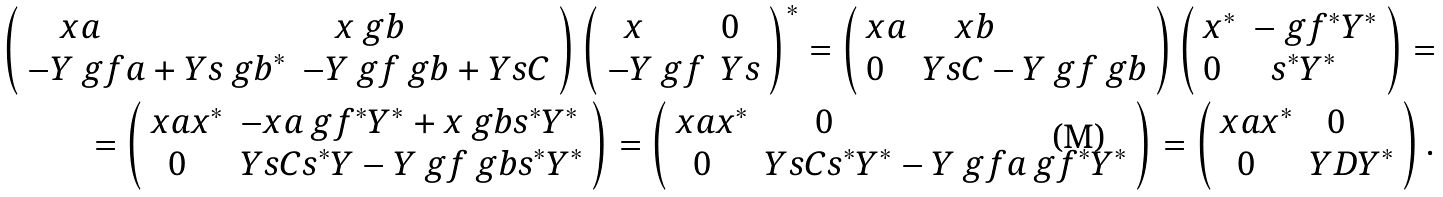Convert formula to latex. <formula><loc_0><loc_0><loc_500><loc_500>\left ( \begin{array} { l l } \quad x a & \quad x \ g b \\ - Y \ g f a + Y s \ g b ^ { * } & - Y \ g f \ g b + Y s C \end{array} \right ) \left ( \begin{array} { l l } \ \ x & 0 \\ - Y \ g f & Y s \end{array} \right ) ^ { * } = \left ( \begin{array} { l l } x a & \quad x b \\ 0 & Y s C - Y \ g f \ g b \end{array} \right ) \left ( \begin{array} { l l } x ^ { * } & - \ g f ^ { * } Y ^ { * } \\ 0 & \ \ s ^ { * } Y ^ { * } \end{array} \right ) = \\ = \left ( \begin{array} { l l } x a x ^ { * } & - x a \ g f ^ { * } Y ^ { * } + x \ g b s ^ { * } Y ^ { * } \\ \ \ 0 & Y s C s ^ { * } Y - Y \ g f \ g b s ^ { * } Y ^ { * } \end{array} \right ) = \left ( \begin{array} { l l } x a x ^ { * } & \quad \ \ 0 \\ \ \ 0 & Y s C s ^ { * } Y ^ { * } - Y \ g f a \ g f ^ { * } Y ^ { * } \end{array} \right ) = \left ( \begin{array} { l l } x a x ^ { * } & \ \ 0 \\ \ \ 0 & Y D Y ^ { * } \end{array} \right ) .</formula> 